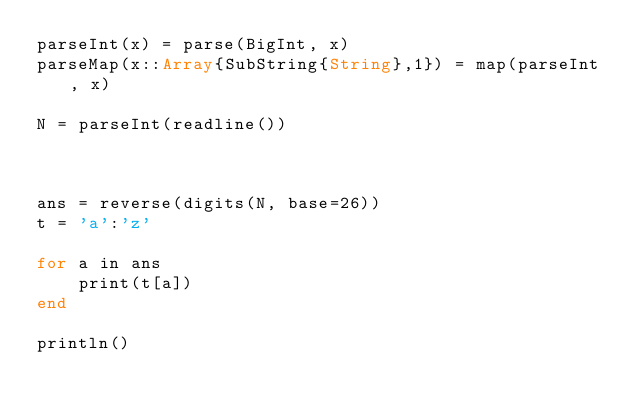<code> <loc_0><loc_0><loc_500><loc_500><_Julia_>parseInt(x) = parse(BigInt, x)
parseMap(x::Array{SubString{String},1}) = map(parseInt, x)

N = parseInt(readline())



ans = reverse(digits(N, base=26))
t = 'a':'z'

for a in ans
    print(t[a])
end

println()</code> 